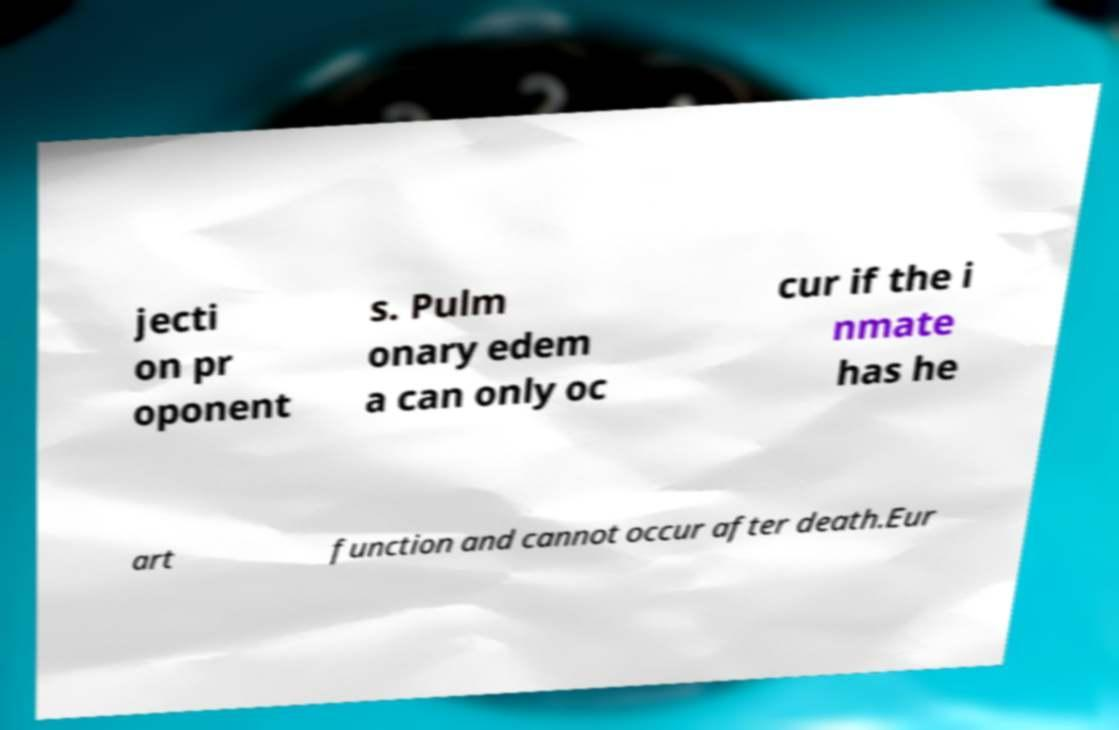Could you extract and type out the text from this image? jecti on pr oponent s. Pulm onary edem a can only oc cur if the i nmate has he art function and cannot occur after death.Eur 